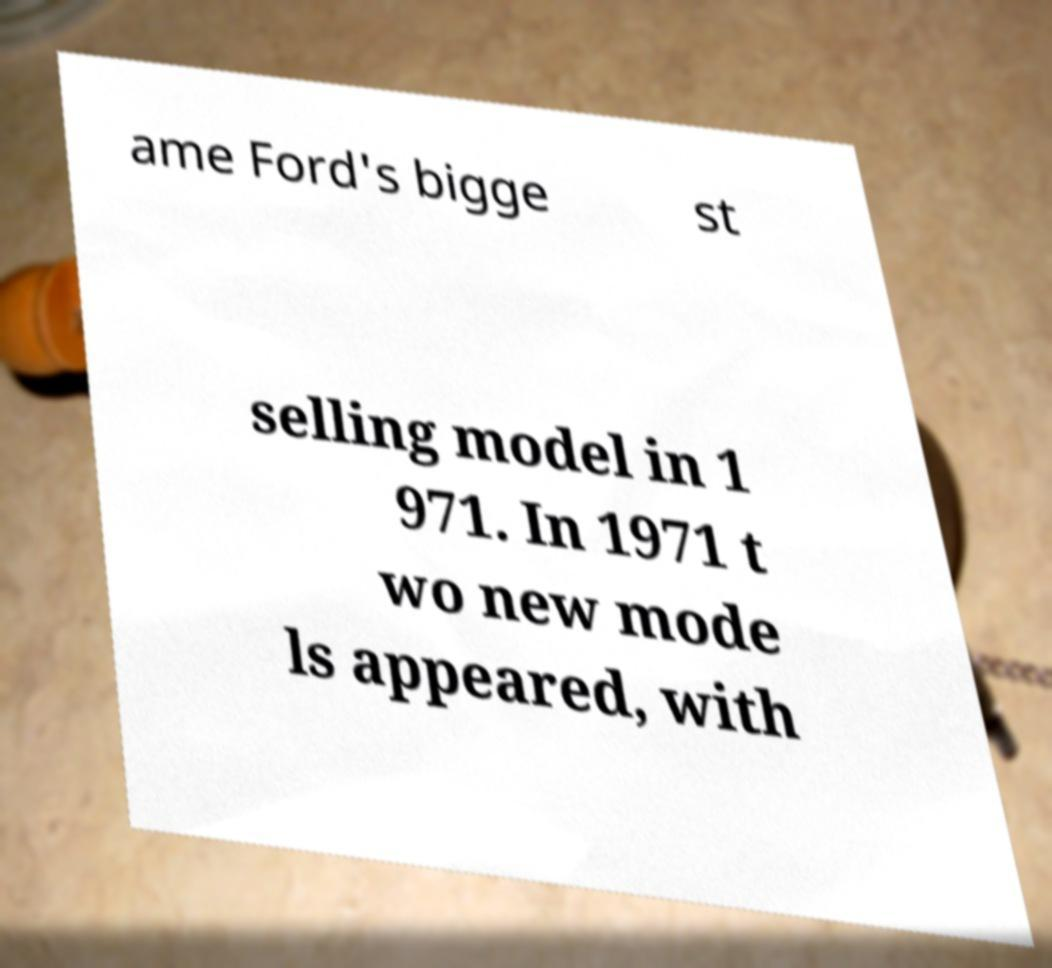For documentation purposes, I need the text within this image transcribed. Could you provide that? ame Ford's bigge st selling model in 1 971. In 1971 t wo new mode ls appeared, with 